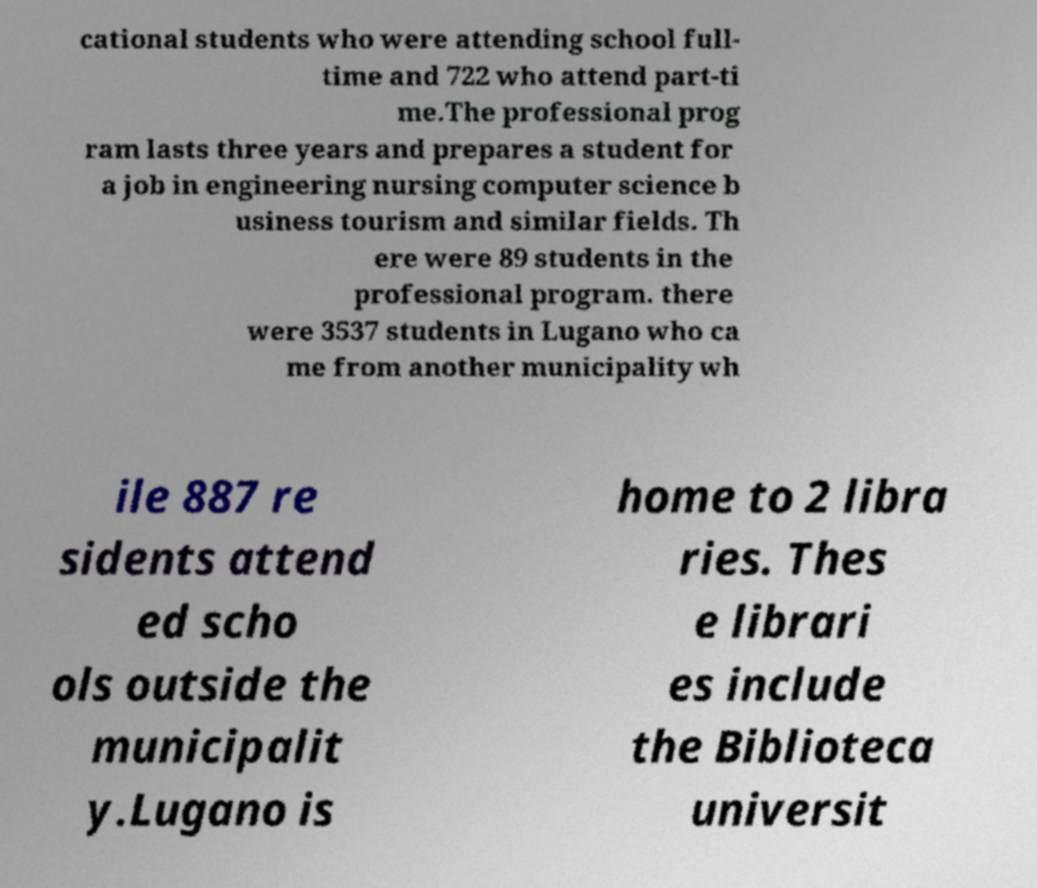I need the written content from this picture converted into text. Can you do that? cational students who were attending school full- time and 722 who attend part-ti me.The professional prog ram lasts three years and prepares a student for a job in engineering nursing computer science b usiness tourism and similar fields. Th ere were 89 students in the professional program. there were 3537 students in Lugano who ca me from another municipality wh ile 887 re sidents attend ed scho ols outside the municipalit y.Lugano is home to 2 libra ries. Thes e librari es include the Biblioteca universit 